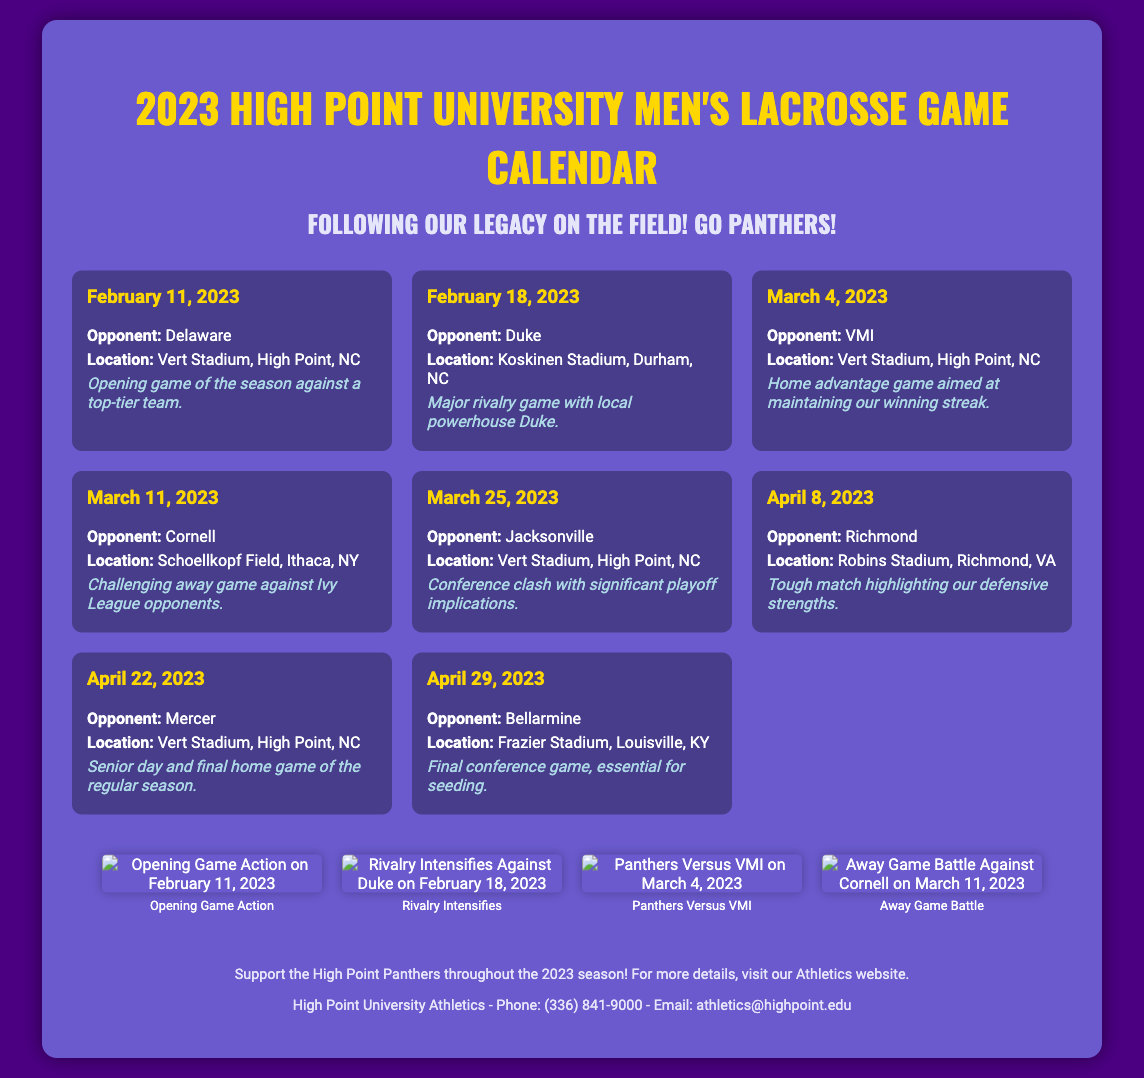What is the opening game date? The opening game is listed as February 11, 2023.
Answer: February 11, 2023 Who is the opponent for the senior day game? The game on April 22, 2023, is against Mercer, which is the senior day game.
Answer: Mercer What location hosts the game against Jacksonville? The game on March 25, 2023, is held at Vert Stadium, High Point, NC.
Answer: Vert Stadium, High Point, NC How many total games are listed in the schedule? There are a total of 8 games detailed in the schedule section.
Answer: 8 What is highlighted about the game against Cornell? The game against Cornell is noted to be a challenging away game against Ivy League opponents.
Answer: Challenging away game against Ivy League opponents Which game has significant playoff implications? The game against Jacksonville on March 25, 2023, is mentioned to have significant playoff implications.
Answer: Jacksonville What is the color scheme of the poster background? The poster background is purple (#4B0082), which contributes to the theme of the document.
Answer: Purple What does the footer suggest about supporting the team? The footer encourages attending the games and supporting the High Point Panthers.
Answer: Support the High Point Panthers 